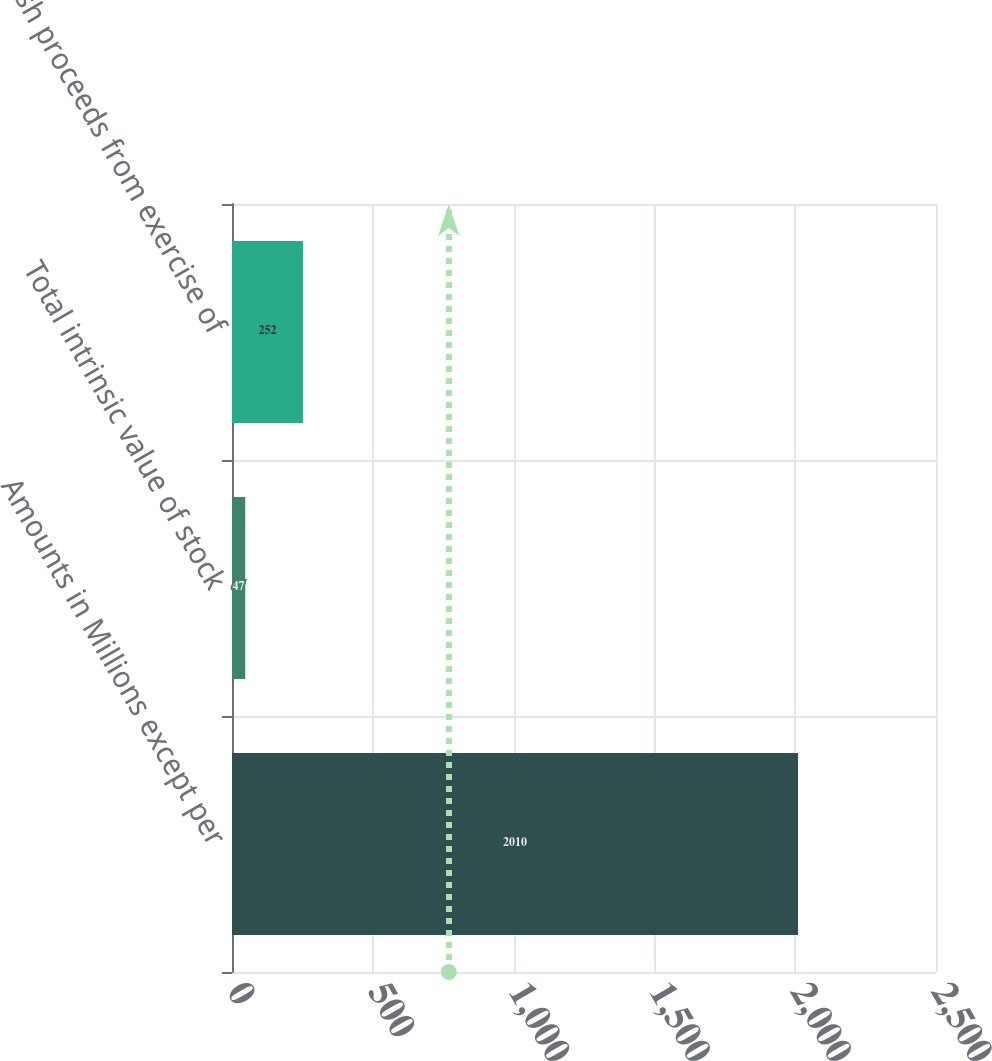Convert chart. <chart><loc_0><loc_0><loc_500><loc_500><bar_chart><fcel>Amounts in Millions except per<fcel>Total intrinsic value of stock<fcel>Cash proceeds from exercise of<nl><fcel>2010<fcel>47<fcel>252<nl></chart> 